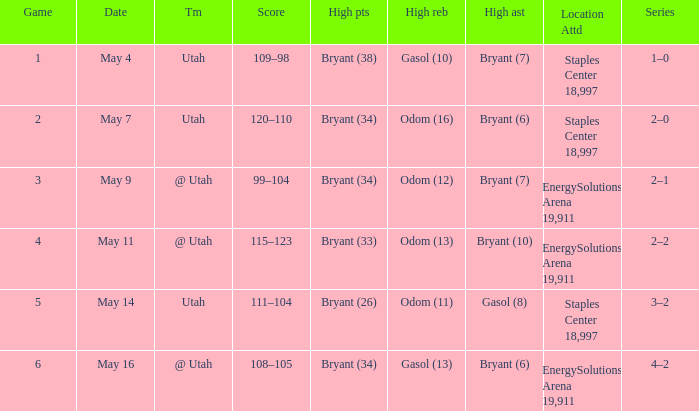What is the Series with a High rebounds with gasol (10)? 1–0. 